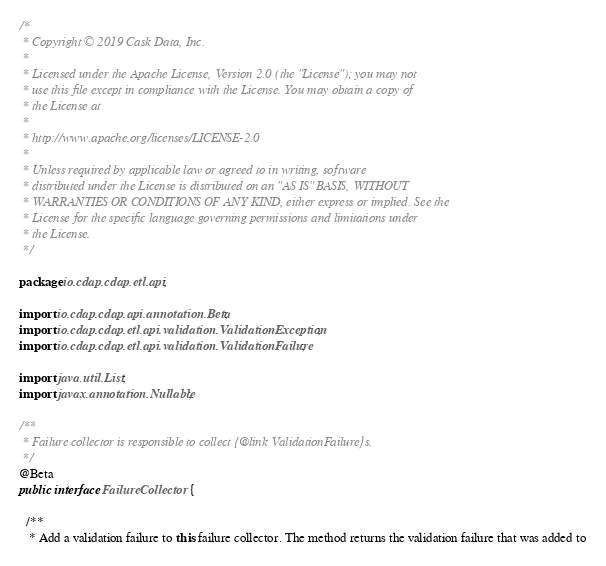Convert code to text. <code><loc_0><loc_0><loc_500><loc_500><_Java_>/*
 * Copyright © 2019 Cask Data, Inc.
 *
 * Licensed under the Apache License, Version 2.0 (the "License"); you may not
 * use this file except in compliance with the License. You may obtain a copy of
 * the License at
 *
 * http://www.apache.org/licenses/LICENSE-2.0
 *
 * Unless required by applicable law or agreed to in writing, software
 * distributed under the License is distributed on an "AS IS" BASIS, WITHOUT
 * WARRANTIES OR CONDITIONS OF ANY KIND, either express or implied. See the
 * License for the specific language governing permissions and limitations under
 * the License.
 */

package io.cdap.cdap.etl.api;

import io.cdap.cdap.api.annotation.Beta;
import io.cdap.cdap.etl.api.validation.ValidationException;
import io.cdap.cdap.etl.api.validation.ValidationFailure;

import java.util.List;
import javax.annotation.Nullable;

/**
 * Failure collector is responsible to collect {@link ValidationFailure}s.
 */
@Beta
public interface FailureCollector {

  /**
   * Add a validation failure to this failure collector. The method returns the validation failure that was added to</code> 